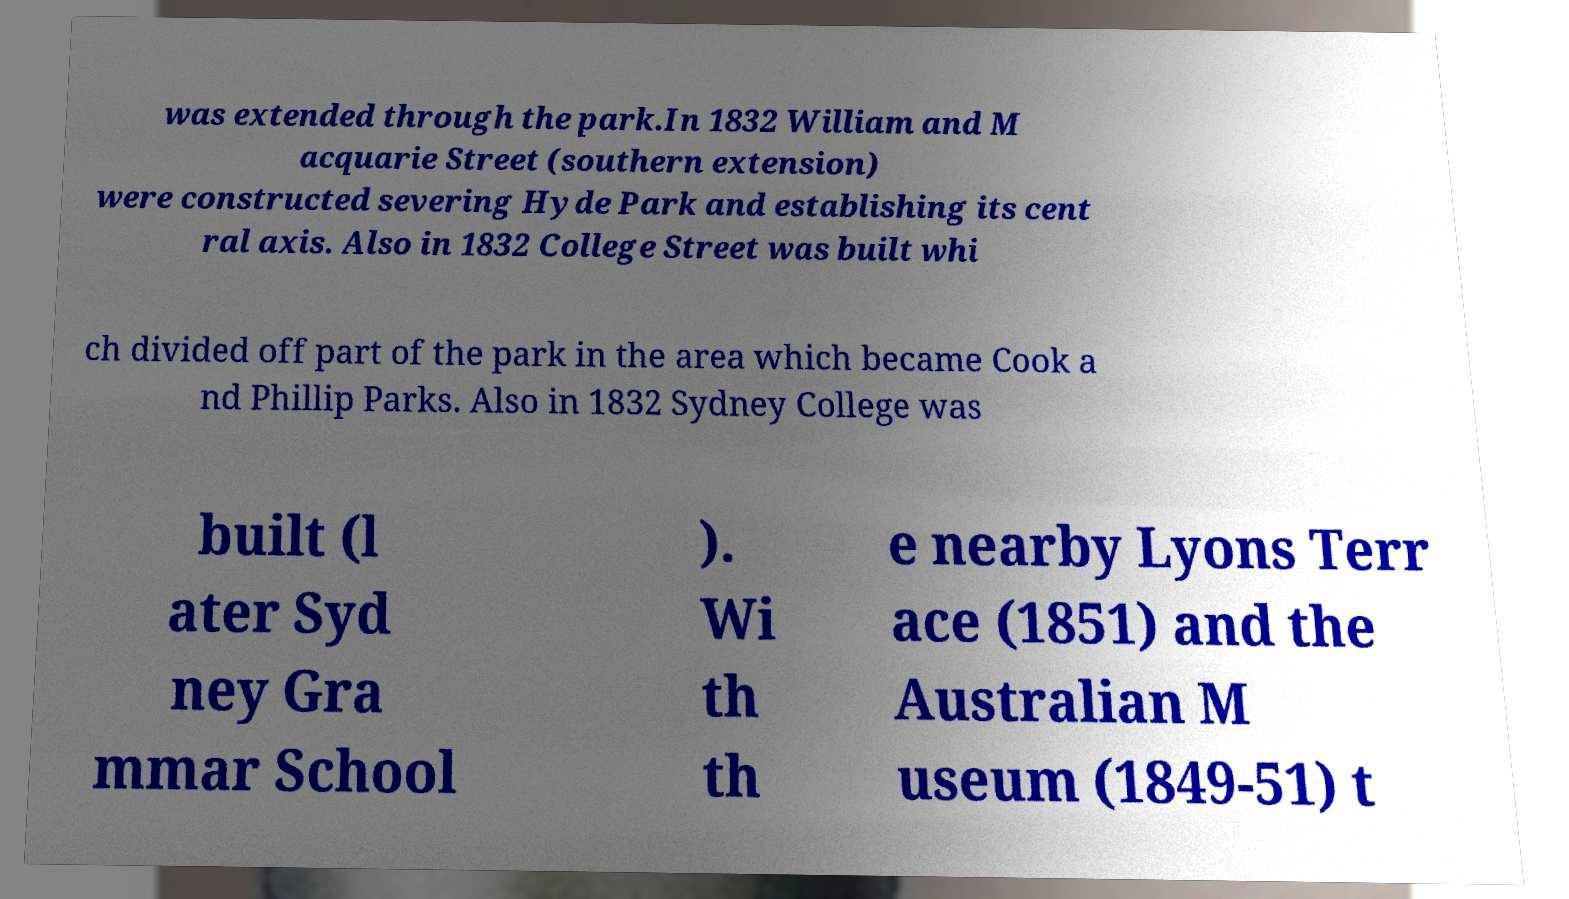Could you extract and type out the text from this image? was extended through the park.In 1832 William and M acquarie Street (southern extension) were constructed severing Hyde Park and establishing its cent ral axis. Also in 1832 College Street was built whi ch divided off part of the park in the area which became Cook a nd Phillip Parks. Also in 1832 Sydney College was built (l ater Syd ney Gra mmar School ). Wi th th e nearby Lyons Terr ace (1851) and the Australian M useum (1849-51) t 